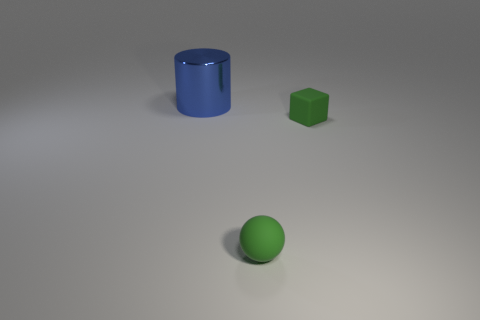Add 3 cylinders. How many objects exist? 6 Subtract all spheres. How many objects are left? 2 Subtract all tiny matte cubes. Subtract all tiny green objects. How many objects are left? 0 Add 3 tiny matte blocks. How many tiny matte blocks are left? 4 Add 3 cubes. How many cubes exist? 4 Subtract 0 purple cylinders. How many objects are left? 3 